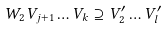<formula> <loc_0><loc_0><loc_500><loc_500>W _ { 2 } V _ { j + 1 } \dots V _ { k } \supseteq V ^ { \prime } _ { 2 } \dots V ^ { \prime } _ { l }</formula> 